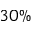Convert formula to latex. <formula><loc_0><loc_0><loc_500><loc_500>3 0 \%</formula> 